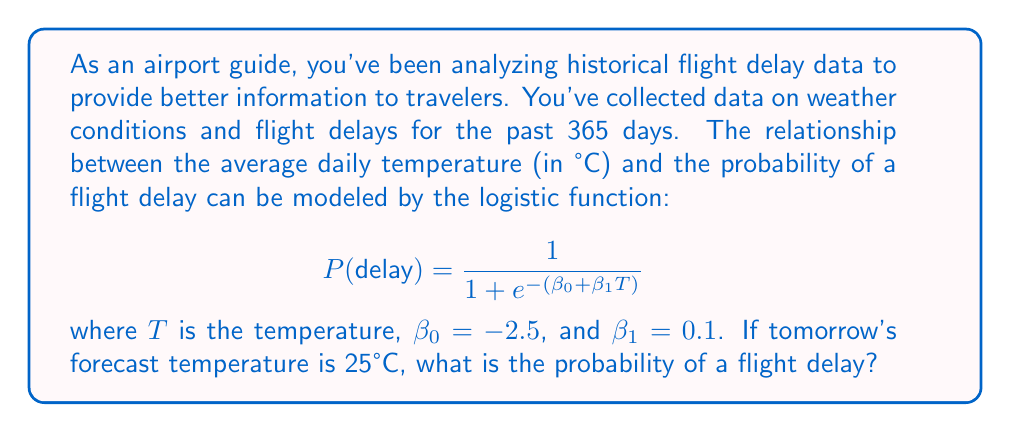Solve this math problem. To solve this problem, we need to follow these steps:

1. Identify the given information:
   - Logistic function: $P(delay) = \frac{1}{1 + e^{-(\beta_0 + \beta_1T)}}$
   - $\beta_0 = -2.5$
   - $\beta_1 = 0.1$
   - Forecast temperature, $T = 25°C$

2. Substitute the values into the logistic function:
   $$ P(delay) = \frac{1}{1 + e^{-(-2.5 + 0.1 \times 25)}} $$

3. Simplify the expression inside the exponential:
   $$ P(delay) = \frac{1}{1 + e^{-(-2.5 + 2.5)}} = \frac{1}{1 + e^{-0}} $$

4. Evaluate $e^{-0}$:
   $$ P(delay) = \frac{1}{1 + 1} = \frac{1}{2} $$

5. Convert the fraction to a decimal or percentage:
   $$ P(delay) = 0.5 \text{ or } 50\% $$

Therefore, based on the given logistic model and the forecast temperature, the probability of a flight delay tomorrow is 0.5 or 50%.
Answer: 0.5 or 50% 